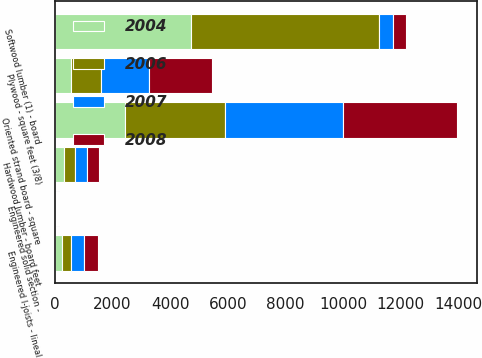<chart> <loc_0><loc_0><loc_500><loc_500><stacked_bar_chart><ecel><fcel>Softwood lumber (1) - board<fcel>Engineered solid section -<fcel>Engineered I-joists - lineal<fcel>Oriented strand board - square<fcel>Plywood - square feet (3/8)<fcel>Hardwood lumber - board feet<nl><fcel>2004<fcel>4722<fcel>23<fcel>227<fcel>2438<fcel>565<fcel>324<nl><fcel>2006<fcel>6538<fcel>30<fcel>338<fcel>3466<fcel>1049<fcel>363<nl><fcel>2007<fcel>470<fcel>36<fcel>456<fcel>4096<fcel>1663<fcel>412<nl><fcel>2008<fcel>470<fcel>38<fcel>484<fcel>3948<fcel>2180<fcel>427<nl></chart> 